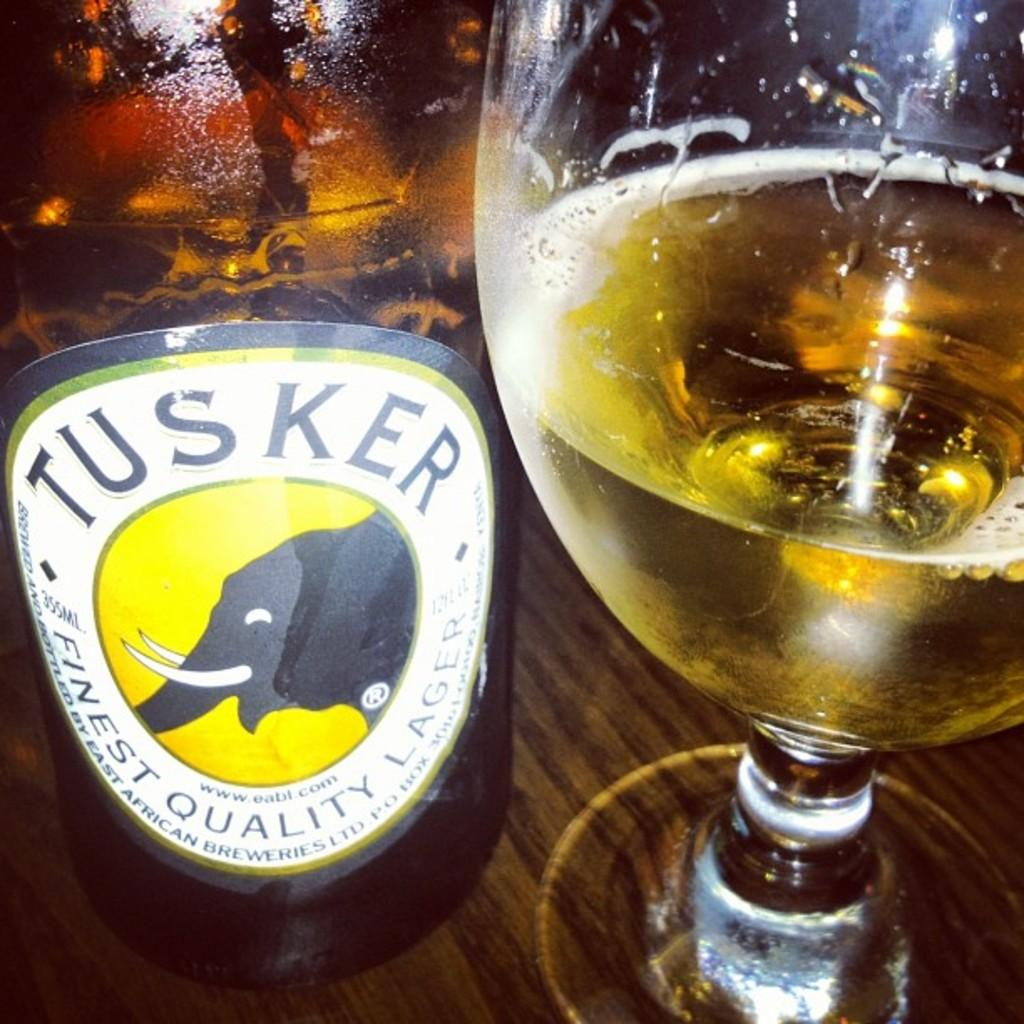<image>
Write a terse but informative summary of the picture. A bottle of Tusker is sitting next to a partially drank glass of beer on a table. 